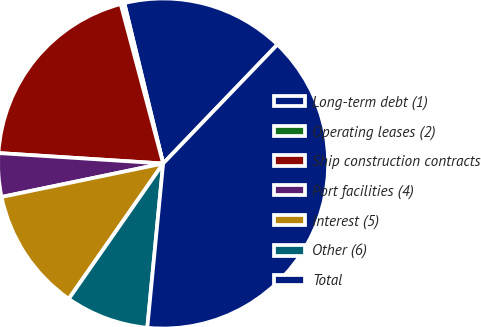Convert chart. <chart><loc_0><loc_0><loc_500><loc_500><pie_chart><fcel>Long-term debt (1)<fcel>Operating leases (2)<fcel>Ship construction contracts<fcel>Port facilities (4)<fcel>Interest (5)<fcel>Other (6)<fcel>Total<nl><fcel>15.96%<fcel>0.36%<fcel>19.85%<fcel>4.26%<fcel>12.06%<fcel>8.16%<fcel>39.35%<nl></chart> 